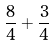<formula> <loc_0><loc_0><loc_500><loc_500>\frac { 8 } { 4 } + \frac { 3 } { 4 }</formula> 